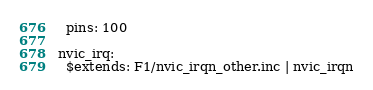Convert code to text. <code><loc_0><loc_0><loc_500><loc_500><_YAML_>  pins: 100

nvic_irq:
  $extends: F1/nvic_irqn_other.inc | nvic_irqn
</code> 